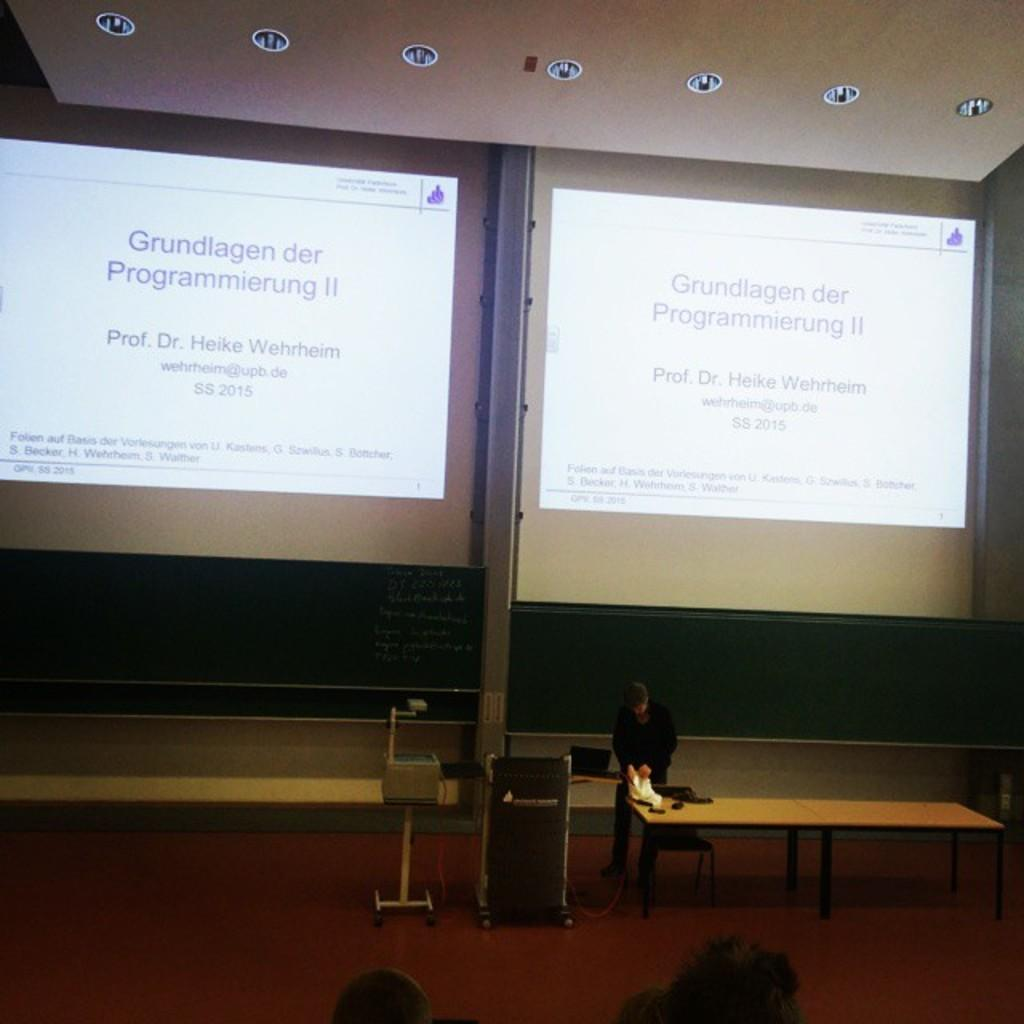What is on the wall in the image? There are screens on the wall. Can you describe the person in the image? There is a person standing in the image. What is on the table in the image? There are items on a table. What device is used for displaying images or videos in the image? There is a projector with a stand in the image. Are there any books or a quill pen visible in the image? No, there are no books or quill pen present in the image. 